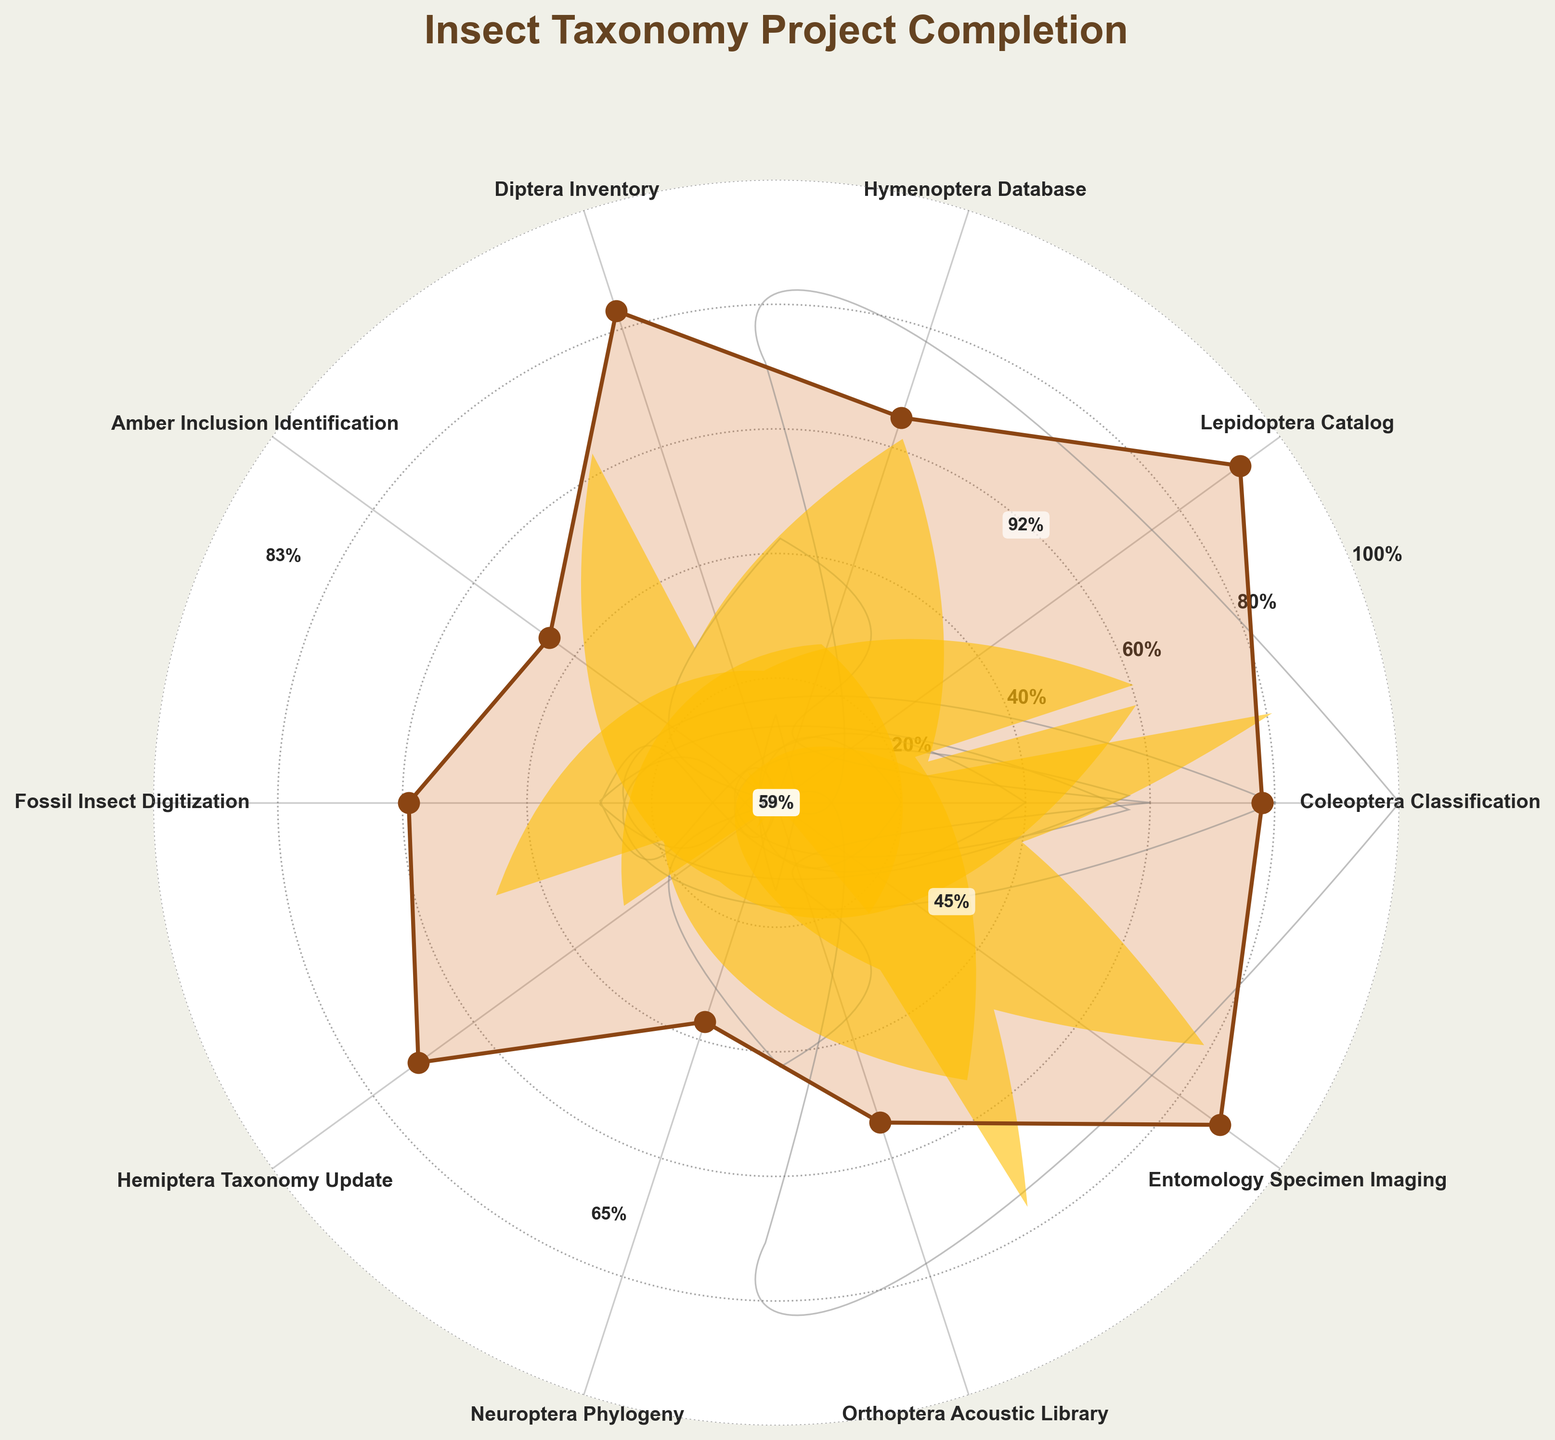What's the title of the figure? The title of the figure is clearly displayed at the top in bold, which reads "Insect Taxonomy Project Completion."
Answer: Insect Taxonomy Project Completion How many projects are represented in the figure? To determine the number of projects, count each unique section (or wedge) labeled around the circle.
Answer: 10 Which project has the highest completion percentage? By examining the values in the center of each wedge, identify the wedge with the highest percentage. The highest value here is 92%, associated with the "Lepidoptera Catalog" project.
Answer: Lepidoptera Catalog Which project has the lowest completion percentage? Similarly, look for the smallest value in the wedges. The lowest value is 37%, which corresponds to the "Neuroptera Phylogeny" project.
Answer: Neuroptera Phylogeny What is the average completion percentage of all projects? First, sum up all the completion percentages: 78 + 92 + 65 + 83 + 45 + 59 + 71 + 37 + 54 + 88 = 672. Then divide by the number of projects, which is 10.
Answer: 67.2% Which projects have completion percentages greater than 80%? Identify all wedges with percentages above 80%: "Lepidoptera Catalog" (92%), "Diptera Inventory" (83%), "Entomology Specimen Imaging" (88%).
Answer: Lepidoptera Catalog, Diptera Inventory, Entomology Specimen Imaging What's the difference in completion percentage between the "Coleoptera Classification" and "Amber Inclusion Identification" projects? Calculate the difference: 78% (Coleoptera Classification) - 45% (Amber Inclusion Identification) = 33%.
Answer: 33% How does the completion percentage of the "Orthoptera Acoustic Library" compare to the "Hymenoptera Database"? Compare the two values: "Orthoptera Acoustic Library" is 54%, and "Hymenoptera Database" is 65%. The "Orthoptera Acoustic Library" has a lower completion percentage.
Answer: Lower What's the general trend of completion percentage across projects? By looking at the values and their overall distribution, the trends show that some projects are close to completion (above 80%), some are at mid-stage (~50-70%), and some are lower (below 50%). The average is around 67.2%, indicating many projects are midway done.
Answer: Mixed, with some high, some mid-stage, and some low completion percentages 